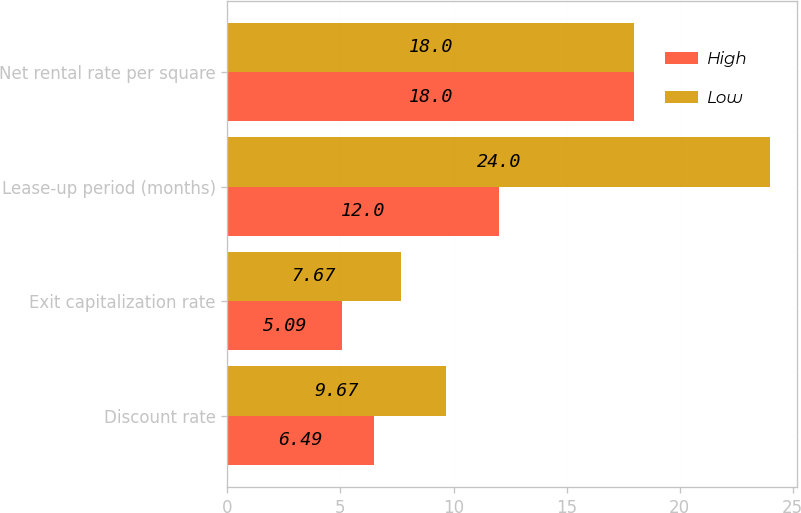<chart> <loc_0><loc_0><loc_500><loc_500><stacked_bar_chart><ecel><fcel>Discount rate<fcel>Exit capitalization rate<fcel>Lease-up period (months)<fcel>Net rental rate per square<nl><fcel>High<fcel>6.49<fcel>5.09<fcel>12<fcel>18<nl><fcel>Low<fcel>9.67<fcel>7.67<fcel>24<fcel>18<nl></chart> 